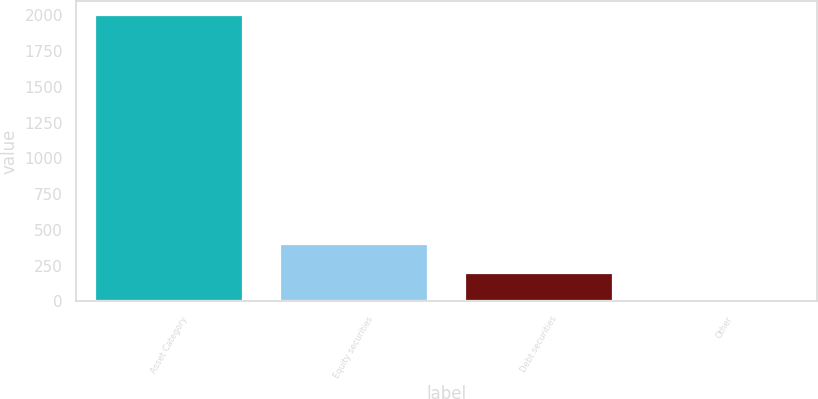Convert chart. <chart><loc_0><loc_0><loc_500><loc_500><bar_chart><fcel>Asset Category<fcel>Equity securities<fcel>Debt securities<fcel>Other<nl><fcel>2004<fcel>401.6<fcel>201.3<fcel>1<nl></chart> 